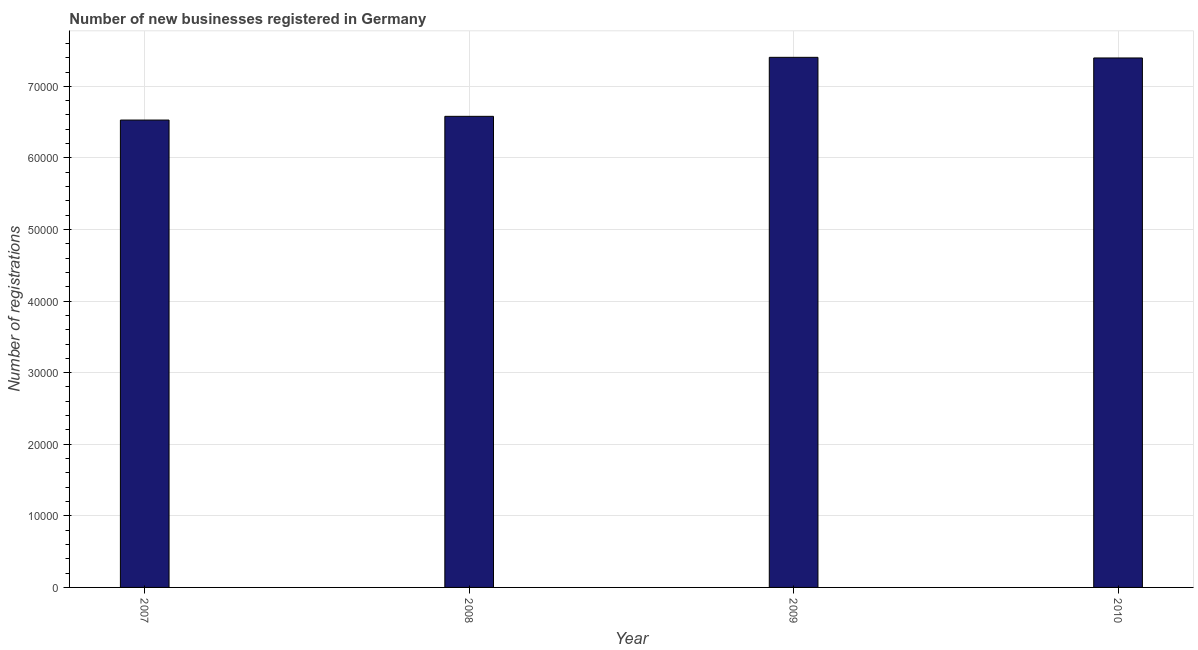Does the graph contain any zero values?
Your answer should be very brief. No. Does the graph contain grids?
Your response must be concise. Yes. What is the title of the graph?
Give a very brief answer. Number of new businesses registered in Germany. What is the label or title of the Y-axis?
Keep it short and to the point. Number of registrations. What is the number of new business registrations in 2010?
Offer a terse response. 7.40e+04. Across all years, what is the maximum number of new business registrations?
Provide a short and direct response. 7.41e+04. Across all years, what is the minimum number of new business registrations?
Make the answer very short. 6.53e+04. In which year was the number of new business registrations maximum?
Give a very brief answer. 2009. In which year was the number of new business registrations minimum?
Your answer should be compact. 2007. What is the sum of the number of new business registrations?
Keep it short and to the point. 2.79e+05. What is the difference between the number of new business registrations in 2007 and 2008?
Ensure brevity in your answer.  -520. What is the average number of new business registrations per year?
Keep it short and to the point. 6.98e+04. What is the median number of new business registrations?
Make the answer very short. 6.99e+04. In how many years, is the number of new business registrations greater than 38000 ?
Give a very brief answer. 4. What is the ratio of the number of new business registrations in 2007 to that in 2010?
Your answer should be compact. 0.88. Is the difference between the number of new business registrations in 2008 and 2010 greater than the difference between any two years?
Your answer should be compact. No. What is the difference between the highest and the second highest number of new business registrations?
Offer a terse response. 89. What is the difference between the highest and the lowest number of new business registrations?
Offer a terse response. 8763. In how many years, is the number of new business registrations greater than the average number of new business registrations taken over all years?
Ensure brevity in your answer.  2. Are the values on the major ticks of Y-axis written in scientific E-notation?
Provide a succinct answer. No. What is the Number of registrations in 2007?
Keep it short and to the point. 6.53e+04. What is the Number of registrations of 2008?
Your answer should be compact. 6.58e+04. What is the Number of registrations in 2009?
Your response must be concise. 7.41e+04. What is the Number of registrations in 2010?
Give a very brief answer. 7.40e+04. What is the difference between the Number of registrations in 2007 and 2008?
Provide a short and direct response. -520. What is the difference between the Number of registrations in 2007 and 2009?
Your answer should be compact. -8763. What is the difference between the Number of registrations in 2007 and 2010?
Your answer should be very brief. -8674. What is the difference between the Number of registrations in 2008 and 2009?
Give a very brief answer. -8243. What is the difference between the Number of registrations in 2008 and 2010?
Offer a very short reply. -8154. What is the difference between the Number of registrations in 2009 and 2010?
Your response must be concise. 89. What is the ratio of the Number of registrations in 2007 to that in 2008?
Keep it short and to the point. 0.99. What is the ratio of the Number of registrations in 2007 to that in 2009?
Your answer should be compact. 0.88. What is the ratio of the Number of registrations in 2007 to that in 2010?
Offer a terse response. 0.88. What is the ratio of the Number of registrations in 2008 to that in 2009?
Offer a very short reply. 0.89. What is the ratio of the Number of registrations in 2008 to that in 2010?
Provide a short and direct response. 0.89. 